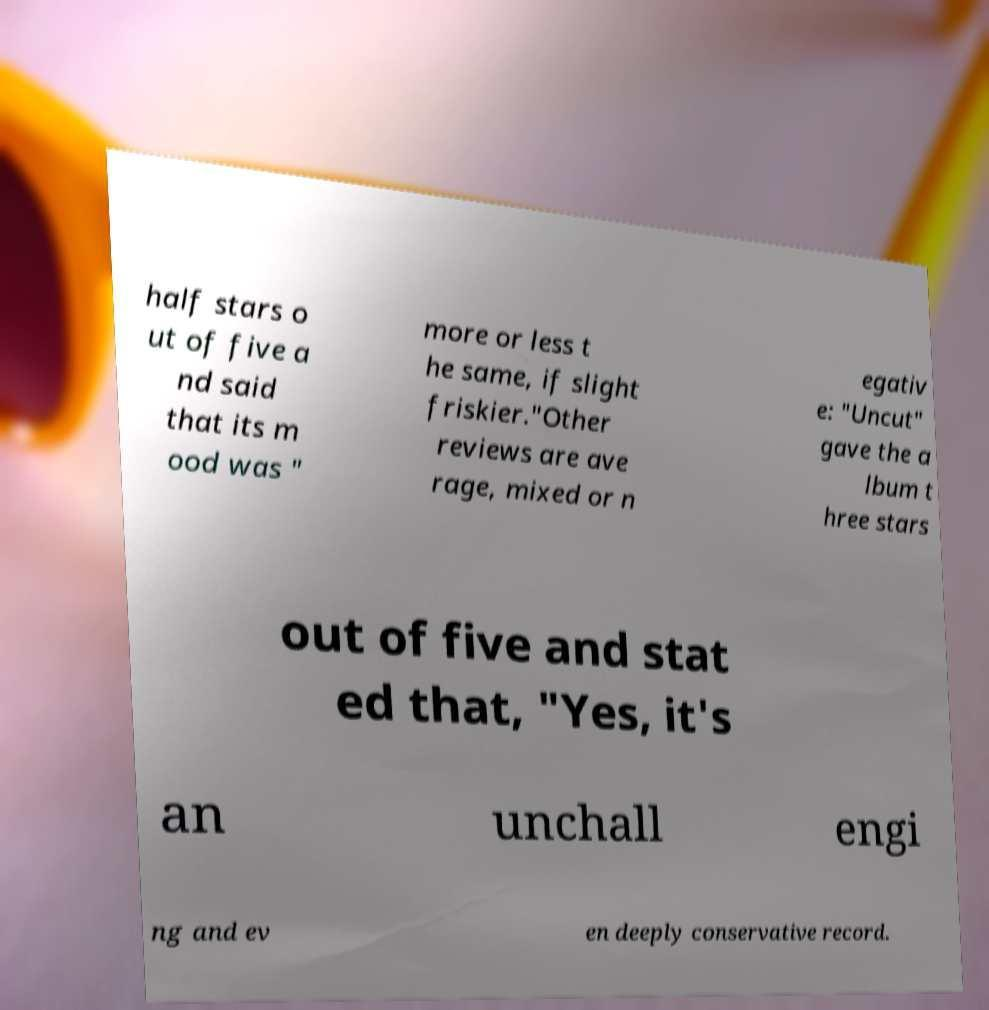I need the written content from this picture converted into text. Can you do that? half stars o ut of five a nd said that its m ood was " more or less t he same, if slight friskier."Other reviews are ave rage, mixed or n egativ e: "Uncut" gave the a lbum t hree stars out of five and stat ed that, "Yes, it's an unchall engi ng and ev en deeply conservative record. 